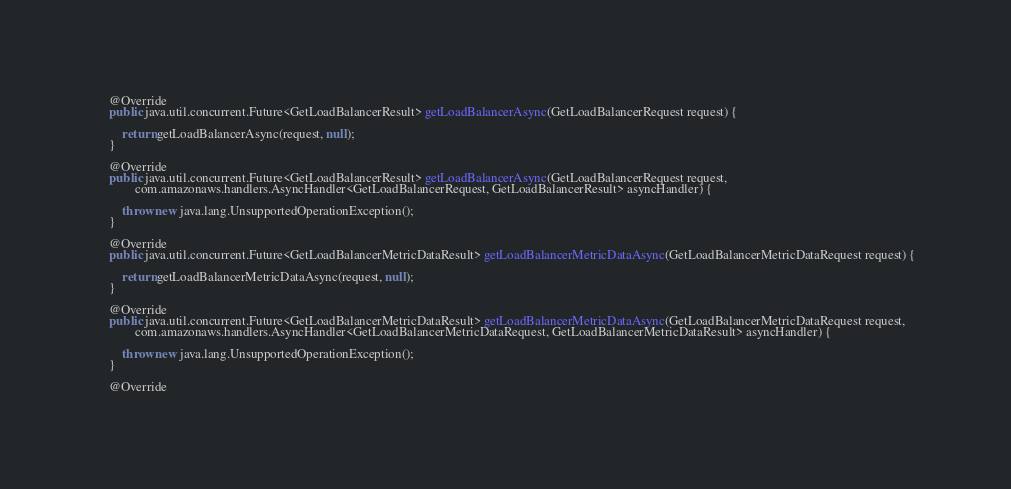<code> <loc_0><loc_0><loc_500><loc_500><_Java_>
    @Override
    public java.util.concurrent.Future<GetLoadBalancerResult> getLoadBalancerAsync(GetLoadBalancerRequest request) {

        return getLoadBalancerAsync(request, null);
    }

    @Override
    public java.util.concurrent.Future<GetLoadBalancerResult> getLoadBalancerAsync(GetLoadBalancerRequest request,
            com.amazonaws.handlers.AsyncHandler<GetLoadBalancerRequest, GetLoadBalancerResult> asyncHandler) {

        throw new java.lang.UnsupportedOperationException();
    }

    @Override
    public java.util.concurrent.Future<GetLoadBalancerMetricDataResult> getLoadBalancerMetricDataAsync(GetLoadBalancerMetricDataRequest request) {

        return getLoadBalancerMetricDataAsync(request, null);
    }

    @Override
    public java.util.concurrent.Future<GetLoadBalancerMetricDataResult> getLoadBalancerMetricDataAsync(GetLoadBalancerMetricDataRequest request,
            com.amazonaws.handlers.AsyncHandler<GetLoadBalancerMetricDataRequest, GetLoadBalancerMetricDataResult> asyncHandler) {

        throw new java.lang.UnsupportedOperationException();
    }

    @Override</code> 